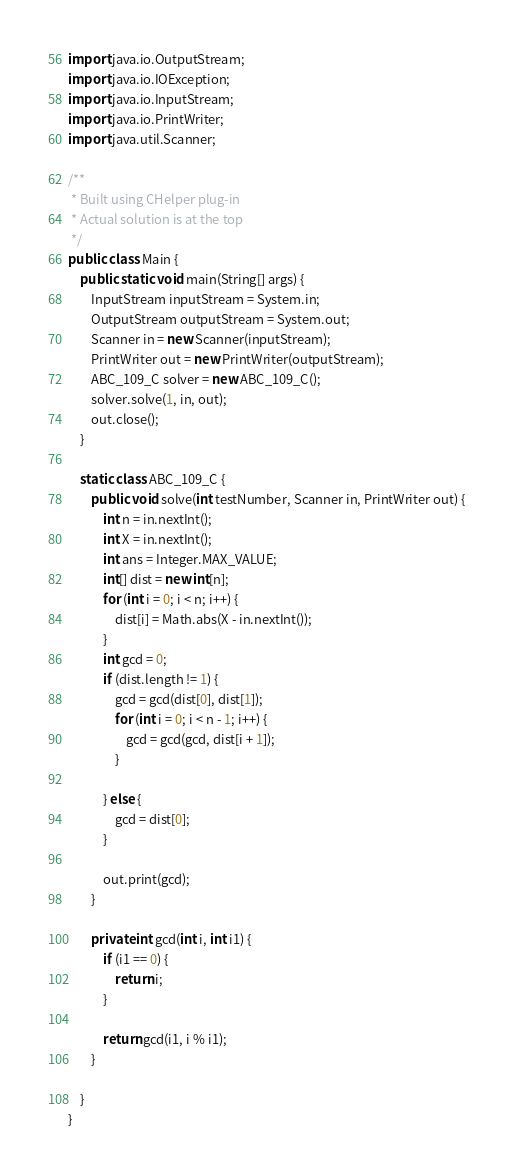Convert code to text. <code><loc_0><loc_0><loc_500><loc_500><_Java_>import java.io.OutputStream;
import java.io.IOException;
import java.io.InputStream;
import java.io.PrintWriter;
import java.util.Scanner;

/**
 * Built using CHelper plug-in
 * Actual solution is at the top
 */
public class Main {
    public static void main(String[] args) {
        InputStream inputStream = System.in;
        OutputStream outputStream = System.out;
        Scanner in = new Scanner(inputStream);
        PrintWriter out = new PrintWriter(outputStream);
        ABC_109_C solver = new ABC_109_C();
        solver.solve(1, in, out);
        out.close();
    }

    static class ABC_109_C {
        public void solve(int testNumber, Scanner in, PrintWriter out) {
            int n = in.nextInt();
            int X = in.nextInt();
            int ans = Integer.MAX_VALUE;
            int[] dist = new int[n];
            for (int i = 0; i < n; i++) {
                dist[i] = Math.abs(X - in.nextInt());
            }
            int gcd = 0;
            if (dist.length != 1) {
                gcd = gcd(dist[0], dist[1]);
                for (int i = 0; i < n - 1; i++) {
                    gcd = gcd(gcd, dist[i + 1]);
                }

            } else {
                gcd = dist[0];
            }

            out.print(gcd);
        }

        private int gcd(int i, int i1) {
            if (i1 == 0) {
                return i;
            }

            return gcd(i1, i % i1);
        }

    }
}

</code> 